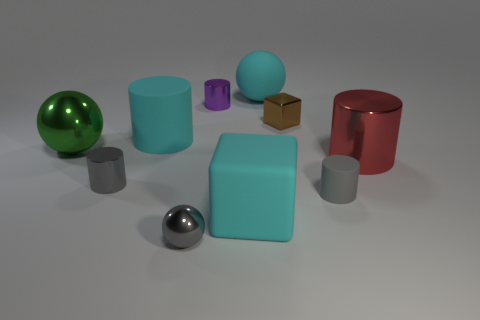What is the size of the block in front of the small brown cube?
Your answer should be very brief. Large. How many other tiny shiny cubes have the same color as the small shiny cube?
Your response must be concise. 0. There is a cyan thing behind the tiny purple cylinder; is there a small metal sphere on the right side of it?
Keep it short and to the point. No. Do the ball that is on the right side of the small purple cylinder and the large metal object that is right of the big cyan rubber cylinder have the same color?
Provide a short and direct response. No. What is the color of the rubber cylinder that is the same size as the brown block?
Offer a terse response. Gray. Are there the same number of tiny gray metal balls in front of the cyan rubber cylinder and cyan matte balls right of the red shiny thing?
Your answer should be compact. No. There is a cyan object on the left side of the tiny cylinder that is behind the large green thing; what is its material?
Your response must be concise. Rubber. How many objects are either brown matte balls or big rubber objects?
Your answer should be very brief. 3. There is a cube that is the same color as the matte ball; what is its size?
Provide a short and direct response. Large. Are there fewer metal blocks than small green shiny cubes?
Your response must be concise. No. 